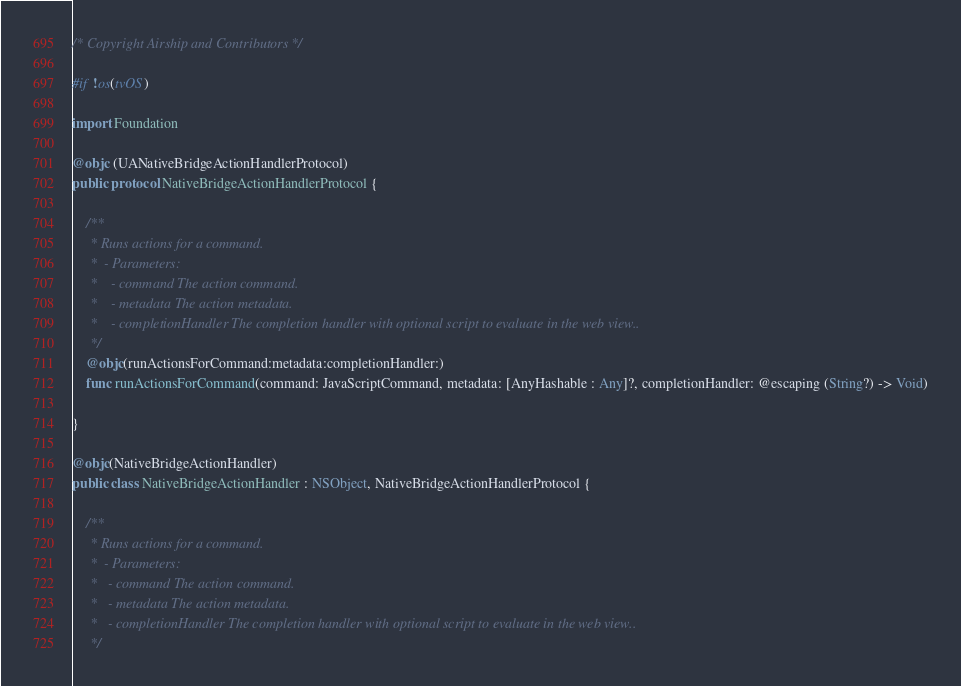<code> <loc_0><loc_0><loc_500><loc_500><_Swift_>/* Copyright Airship and Contributors */

#if !os(tvOS)

import Foundation

@objc (UANativeBridgeActionHandlerProtocol)
public protocol NativeBridgeActionHandlerProtocol {
    
    /**
     * Runs actions for a command.
     *  - Parameters:
     *    - command The action command.
     *    - metadata The action metadata.
     *    - completionHandler The completion handler with optional script to evaluate in the web view..
     */
    @objc(runActionsForCommand:metadata:completionHandler:)
    func runActionsForCommand(command: JavaScriptCommand, metadata: [AnyHashable : Any]?, completionHandler: @escaping (String?) -> Void)
    
}

@objc(NativeBridgeActionHandler)
public class NativeBridgeActionHandler : NSObject, NativeBridgeActionHandlerProtocol {
    
    /**
     * Runs actions for a command.
     *  - Parameters:
     *   - command The action command.
     *   - metadata The action metadata.
     *   - completionHandler The completion handler with optional script to evaluate in the web view..
     */</code> 